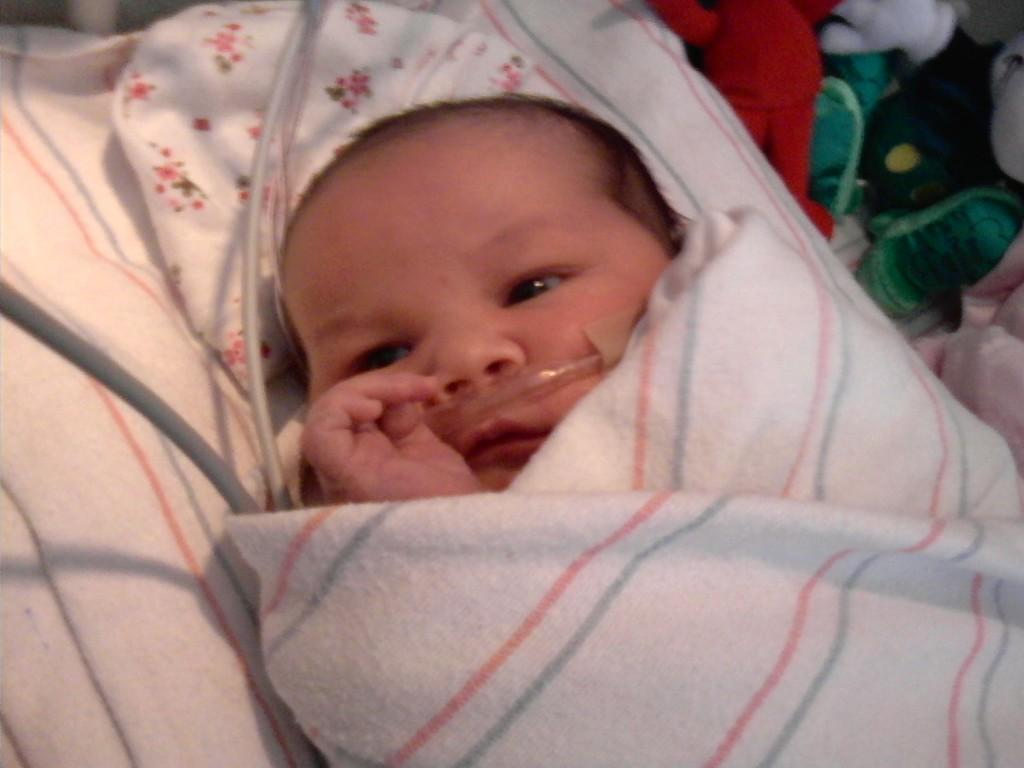What is the main subject of the image? There is a baby in the image. How is the baby dressed or covered? The baby is wrapped in cloth. What else can be seen in the image besides the baby? There are wires visible in the image. Are there any objects near the baby? Yes, there are objects around the baby. What question does the baby ask in the image? Babies cannot ask questions, as they are not capable of verbal communication. 